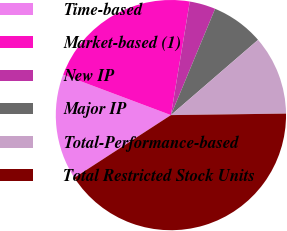<chart> <loc_0><loc_0><loc_500><loc_500><pie_chart><fcel>Time-based<fcel>Market-based (1)<fcel>New IP<fcel>Major IP<fcel>Total-Performance-based<fcel>Total Restricted Stock Units<nl><fcel>14.87%<fcel>21.91%<fcel>3.65%<fcel>7.39%<fcel>11.13%<fcel>41.05%<nl></chart> 